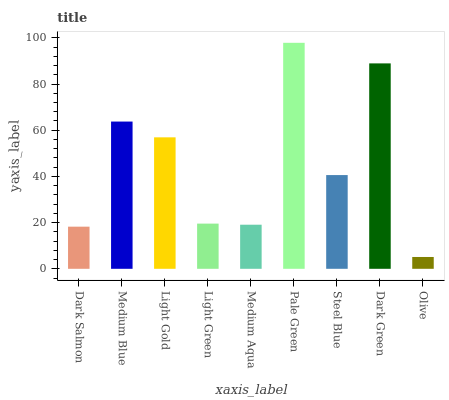Is Medium Blue the minimum?
Answer yes or no. No. Is Medium Blue the maximum?
Answer yes or no. No. Is Medium Blue greater than Dark Salmon?
Answer yes or no. Yes. Is Dark Salmon less than Medium Blue?
Answer yes or no. Yes. Is Dark Salmon greater than Medium Blue?
Answer yes or no. No. Is Medium Blue less than Dark Salmon?
Answer yes or no. No. Is Steel Blue the high median?
Answer yes or no. Yes. Is Steel Blue the low median?
Answer yes or no. Yes. Is Pale Green the high median?
Answer yes or no. No. Is Medium Blue the low median?
Answer yes or no. No. 